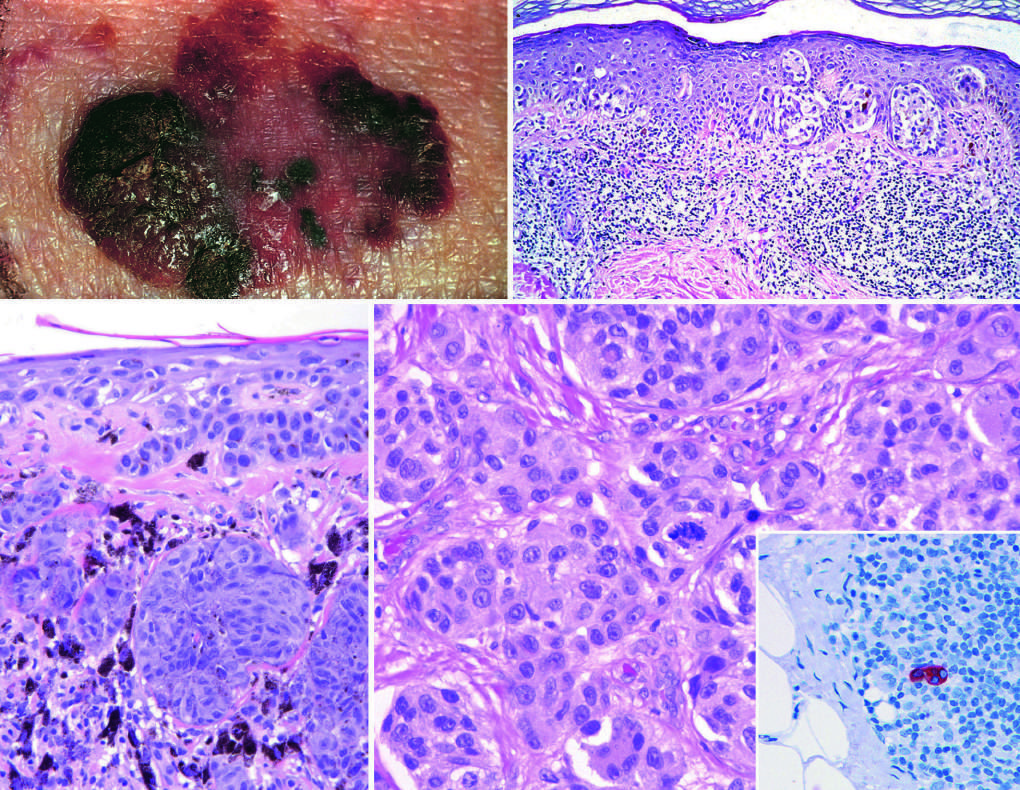what indicates dermal invasion (vertical growth)?
Answer the question using a single word or phrase. Elevated areas 